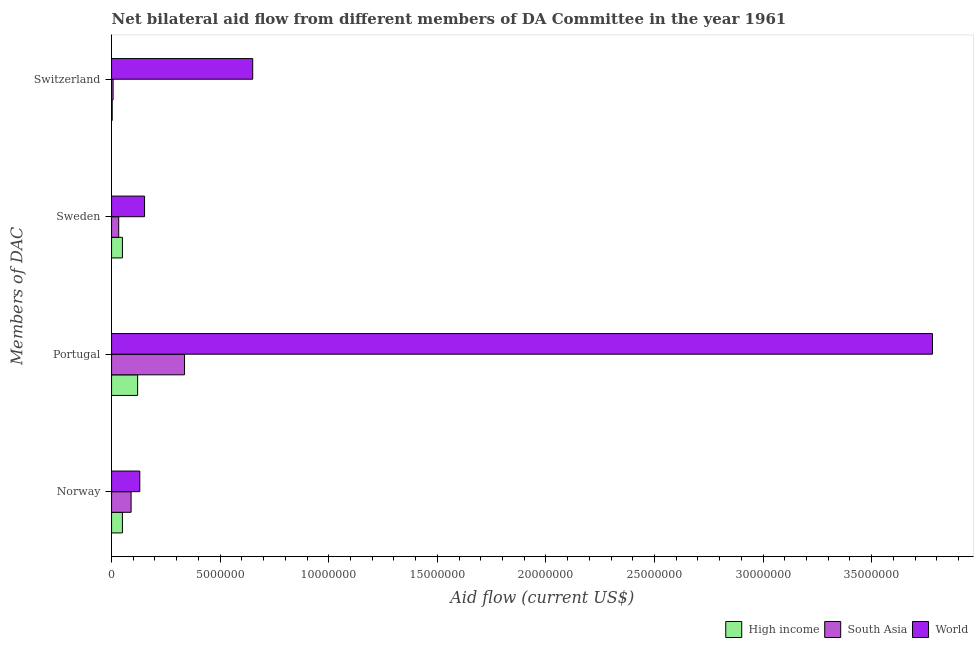How many different coloured bars are there?
Offer a terse response. 3. Are the number of bars per tick equal to the number of legend labels?
Keep it short and to the point. Yes. What is the label of the 2nd group of bars from the top?
Keep it short and to the point. Sweden. What is the amount of aid given by sweden in High income?
Make the answer very short. 5.00e+05. Across all countries, what is the maximum amount of aid given by norway?
Your response must be concise. 1.30e+06. Across all countries, what is the minimum amount of aid given by norway?
Make the answer very short. 5.00e+05. In which country was the amount of aid given by switzerland maximum?
Make the answer very short. World. What is the total amount of aid given by portugal in the graph?
Give a very brief answer. 4.24e+07. What is the difference between the amount of aid given by sweden in World and that in South Asia?
Keep it short and to the point. 1.19e+06. What is the difference between the amount of aid given by portugal in High income and the amount of aid given by switzerland in World?
Provide a succinct answer. -5.30e+06. What is the average amount of aid given by portugal per country?
Provide a short and direct response. 1.41e+07. What is the difference between the amount of aid given by portugal and amount of aid given by switzerland in South Asia?
Offer a terse response. 3.29e+06. What is the ratio of the amount of aid given by switzerland in High income to that in South Asia?
Ensure brevity in your answer.  0.43. Is the amount of aid given by norway in South Asia less than that in World?
Your answer should be very brief. Yes. What is the difference between the highest and the second highest amount of aid given by switzerland?
Give a very brief answer. 6.43e+06. What is the difference between the highest and the lowest amount of aid given by switzerland?
Your answer should be compact. 6.47e+06. In how many countries, is the amount of aid given by portugal greater than the average amount of aid given by portugal taken over all countries?
Provide a short and direct response. 1. Is the sum of the amount of aid given by norway in World and High income greater than the maximum amount of aid given by switzerland across all countries?
Provide a succinct answer. No. Is it the case that in every country, the sum of the amount of aid given by portugal and amount of aid given by sweden is greater than the sum of amount of aid given by switzerland and amount of aid given by norway?
Offer a very short reply. No. What does the 1st bar from the top in Norway represents?
Your answer should be very brief. World. What does the 1st bar from the bottom in Portugal represents?
Provide a succinct answer. High income. Is it the case that in every country, the sum of the amount of aid given by norway and amount of aid given by portugal is greater than the amount of aid given by sweden?
Your answer should be compact. Yes. How many bars are there?
Your answer should be very brief. 12. How many countries are there in the graph?
Provide a succinct answer. 3. What is the difference between two consecutive major ticks on the X-axis?
Ensure brevity in your answer.  5.00e+06. Are the values on the major ticks of X-axis written in scientific E-notation?
Ensure brevity in your answer.  No. Does the graph contain any zero values?
Give a very brief answer. No. Does the graph contain grids?
Your answer should be compact. No. Where does the legend appear in the graph?
Ensure brevity in your answer.  Bottom right. How many legend labels are there?
Your response must be concise. 3. How are the legend labels stacked?
Offer a very short reply. Horizontal. What is the title of the graph?
Provide a succinct answer. Net bilateral aid flow from different members of DA Committee in the year 1961. What is the label or title of the X-axis?
Your answer should be compact. Aid flow (current US$). What is the label or title of the Y-axis?
Keep it short and to the point. Members of DAC. What is the Aid flow (current US$) of High income in Norway?
Give a very brief answer. 5.00e+05. What is the Aid flow (current US$) of South Asia in Norway?
Provide a short and direct response. 9.00e+05. What is the Aid flow (current US$) of World in Norway?
Offer a very short reply. 1.30e+06. What is the Aid flow (current US$) of High income in Portugal?
Make the answer very short. 1.20e+06. What is the Aid flow (current US$) in South Asia in Portugal?
Offer a very short reply. 3.36e+06. What is the Aid flow (current US$) in World in Portugal?
Your response must be concise. 3.78e+07. What is the Aid flow (current US$) of High income in Sweden?
Your answer should be very brief. 5.00e+05. What is the Aid flow (current US$) in South Asia in Sweden?
Your answer should be very brief. 3.30e+05. What is the Aid flow (current US$) in World in Sweden?
Provide a succinct answer. 1.52e+06. What is the Aid flow (current US$) in World in Switzerland?
Offer a very short reply. 6.50e+06. Across all Members of DAC, what is the maximum Aid flow (current US$) in High income?
Make the answer very short. 1.20e+06. Across all Members of DAC, what is the maximum Aid flow (current US$) in South Asia?
Your answer should be compact. 3.36e+06. Across all Members of DAC, what is the maximum Aid flow (current US$) of World?
Your answer should be compact. 3.78e+07. Across all Members of DAC, what is the minimum Aid flow (current US$) in South Asia?
Offer a very short reply. 7.00e+04. Across all Members of DAC, what is the minimum Aid flow (current US$) in World?
Your answer should be very brief. 1.30e+06. What is the total Aid flow (current US$) of High income in the graph?
Ensure brevity in your answer.  2.23e+06. What is the total Aid flow (current US$) in South Asia in the graph?
Provide a succinct answer. 4.66e+06. What is the total Aid flow (current US$) in World in the graph?
Keep it short and to the point. 4.71e+07. What is the difference between the Aid flow (current US$) in High income in Norway and that in Portugal?
Provide a succinct answer. -7.00e+05. What is the difference between the Aid flow (current US$) of South Asia in Norway and that in Portugal?
Give a very brief answer. -2.46e+06. What is the difference between the Aid flow (current US$) of World in Norway and that in Portugal?
Offer a terse response. -3.65e+07. What is the difference between the Aid flow (current US$) in High income in Norway and that in Sweden?
Your response must be concise. 0. What is the difference between the Aid flow (current US$) in South Asia in Norway and that in Sweden?
Provide a short and direct response. 5.70e+05. What is the difference between the Aid flow (current US$) of South Asia in Norway and that in Switzerland?
Ensure brevity in your answer.  8.30e+05. What is the difference between the Aid flow (current US$) in World in Norway and that in Switzerland?
Offer a terse response. -5.20e+06. What is the difference between the Aid flow (current US$) in South Asia in Portugal and that in Sweden?
Ensure brevity in your answer.  3.03e+06. What is the difference between the Aid flow (current US$) of World in Portugal and that in Sweden?
Make the answer very short. 3.63e+07. What is the difference between the Aid flow (current US$) of High income in Portugal and that in Switzerland?
Your answer should be very brief. 1.17e+06. What is the difference between the Aid flow (current US$) of South Asia in Portugal and that in Switzerland?
Offer a very short reply. 3.29e+06. What is the difference between the Aid flow (current US$) of World in Portugal and that in Switzerland?
Your response must be concise. 3.13e+07. What is the difference between the Aid flow (current US$) of South Asia in Sweden and that in Switzerland?
Ensure brevity in your answer.  2.60e+05. What is the difference between the Aid flow (current US$) of World in Sweden and that in Switzerland?
Make the answer very short. -4.98e+06. What is the difference between the Aid flow (current US$) in High income in Norway and the Aid flow (current US$) in South Asia in Portugal?
Provide a succinct answer. -2.86e+06. What is the difference between the Aid flow (current US$) of High income in Norway and the Aid flow (current US$) of World in Portugal?
Provide a short and direct response. -3.73e+07. What is the difference between the Aid flow (current US$) in South Asia in Norway and the Aid flow (current US$) in World in Portugal?
Provide a short and direct response. -3.69e+07. What is the difference between the Aid flow (current US$) in High income in Norway and the Aid flow (current US$) in South Asia in Sweden?
Provide a short and direct response. 1.70e+05. What is the difference between the Aid flow (current US$) in High income in Norway and the Aid flow (current US$) in World in Sweden?
Keep it short and to the point. -1.02e+06. What is the difference between the Aid flow (current US$) of South Asia in Norway and the Aid flow (current US$) of World in Sweden?
Give a very brief answer. -6.20e+05. What is the difference between the Aid flow (current US$) in High income in Norway and the Aid flow (current US$) in South Asia in Switzerland?
Give a very brief answer. 4.30e+05. What is the difference between the Aid flow (current US$) of High income in Norway and the Aid flow (current US$) of World in Switzerland?
Provide a succinct answer. -6.00e+06. What is the difference between the Aid flow (current US$) of South Asia in Norway and the Aid flow (current US$) of World in Switzerland?
Provide a succinct answer. -5.60e+06. What is the difference between the Aid flow (current US$) of High income in Portugal and the Aid flow (current US$) of South Asia in Sweden?
Keep it short and to the point. 8.70e+05. What is the difference between the Aid flow (current US$) in High income in Portugal and the Aid flow (current US$) in World in Sweden?
Offer a terse response. -3.20e+05. What is the difference between the Aid flow (current US$) in South Asia in Portugal and the Aid flow (current US$) in World in Sweden?
Keep it short and to the point. 1.84e+06. What is the difference between the Aid flow (current US$) in High income in Portugal and the Aid flow (current US$) in South Asia in Switzerland?
Offer a very short reply. 1.13e+06. What is the difference between the Aid flow (current US$) in High income in Portugal and the Aid flow (current US$) in World in Switzerland?
Provide a succinct answer. -5.30e+06. What is the difference between the Aid flow (current US$) of South Asia in Portugal and the Aid flow (current US$) of World in Switzerland?
Make the answer very short. -3.14e+06. What is the difference between the Aid flow (current US$) in High income in Sweden and the Aid flow (current US$) in South Asia in Switzerland?
Provide a succinct answer. 4.30e+05. What is the difference between the Aid flow (current US$) in High income in Sweden and the Aid flow (current US$) in World in Switzerland?
Your answer should be very brief. -6.00e+06. What is the difference between the Aid flow (current US$) in South Asia in Sweden and the Aid flow (current US$) in World in Switzerland?
Give a very brief answer. -6.17e+06. What is the average Aid flow (current US$) of High income per Members of DAC?
Keep it short and to the point. 5.58e+05. What is the average Aid flow (current US$) of South Asia per Members of DAC?
Your response must be concise. 1.16e+06. What is the average Aid flow (current US$) of World per Members of DAC?
Make the answer very short. 1.18e+07. What is the difference between the Aid flow (current US$) of High income and Aid flow (current US$) of South Asia in Norway?
Provide a succinct answer. -4.00e+05. What is the difference between the Aid flow (current US$) in High income and Aid flow (current US$) in World in Norway?
Provide a succinct answer. -8.00e+05. What is the difference between the Aid flow (current US$) in South Asia and Aid flow (current US$) in World in Norway?
Ensure brevity in your answer.  -4.00e+05. What is the difference between the Aid flow (current US$) of High income and Aid flow (current US$) of South Asia in Portugal?
Offer a very short reply. -2.16e+06. What is the difference between the Aid flow (current US$) in High income and Aid flow (current US$) in World in Portugal?
Give a very brief answer. -3.66e+07. What is the difference between the Aid flow (current US$) of South Asia and Aid flow (current US$) of World in Portugal?
Keep it short and to the point. -3.44e+07. What is the difference between the Aid flow (current US$) of High income and Aid flow (current US$) of World in Sweden?
Offer a very short reply. -1.02e+06. What is the difference between the Aid flow (current US$) in South Asia and Aid flow (current US$) in World in Sweden?
Ensure brevity in your answer.  -1.19e+06. What is the difference between the Aid flow (current US$) in High income and Aid flow (current US$) in South Asia in Switzerland?
Make the answer very short. -4.00e+04. What is the difference between the Aid flow (current US$) in High income and Aid flow (current US$) in World in Switzerland?
Your answer should be compact. -6.47e+06. What is the difference between the Aid flow (current US$) in South Asia and Aid flow (current US$) in World in Switzerland?
Your response must be concise. -6.43e+06. What is the ratio of the Aid flow (current US$) in High income in Norway to that in Portugal?
Offer a terse response. 0.42. What is the ratio of the Aid flow (current US$) in South Asia in Norway to that in Portugal?
Keep it short and to the point. 0.27. What is the ratio of the Aid flow (current US$) in World in Norway to that in Portugal?
Offer a terse response. 0.03. What is the ratio of the Aid flow (current US$) in South Asia in Norway to that in Sweden?
Give a very brief answer. 2.73. What is the ratio of the Aid flow (current US$) of World in Norway to that in Sweden?
Offer a terse response. 0.86. What is the ratio of the Aid flow (current US$) of High income in Norway to that in Switzerland?
Provide a short and direct response. 16.67. What is the ratio of the Aid flow (current US$) in South Asia in Norway to that in Switzerland?
Your answer should be very brief. 12.86. What is the ratio of the Aid flow (current US$) of South Asia in Portugal to that in Sweden?
Ensure brevity in your answer.  10.18. What is the ratio of the Aid flow (current US$) in World in Portugal to that in Sweden?
Keep it short and to the point. 24.87. What is the ratio of the Aid flow (current US$) in World in Portugal to that in Switzerland?
Make the answer very short. 5.82. What is the ratio of the Aid flow (current US$) in High income in Sweden to that in Switzerland?
Provide a short and direct response. 16.67. What is the ratio of the Aid flow (current US$) in South Asia in Sweden to that in Switzerland?
Your answer should be very brief. 4.71. What is the ratio of the Aid flow (current US$) of World in Sweden to that in Switzerland?
Offer a terse response. 0.23. What is the difference between the highest and the second highest Aid flow (current US$) in South Asia?
Your response must be concise. 2.46e+06. What is the difference between the highest and the second highest Aid flow (current US$) of World?
Make the answer very short. 3.13e+07. What is the difference between the highest and the lowest Aid flow (current US$) of High income?
Give a very brief answer. 1.17e+06. What is the difference between the highest and the lowest Aid flow (current US$) in South Asia?
Provide a short and direct response. 3.29e+06. What is the difference between the highest and the lowest Aid flow (current US$) of World?
Provide a short and direct response. 3.65e+07. 